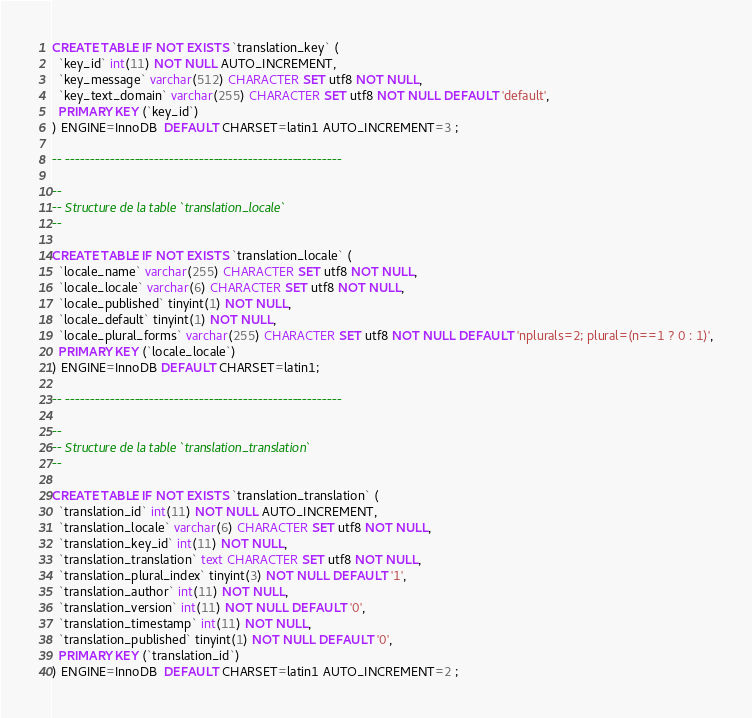Convert code to text. <code><loc_0><loc_0><loc_500><loc_500><_SQL_>
CREATE TABLE IF NOT EXISTS `translation_key` (
  `key_id` int(11) NOT NULL AUTO_INCREMENT,
  `key_message` varchar(512) CHARACTER SET utf8 NOT NULL,
  `key_text_domain` varchar(255) CHARACTER SET utf8 NOT NULL DEFAULT 'default',
  PRIMARY KEY (`key_id`)
) ENGINE=InnoDB  DEFAULT CHARSET=latin1 AUTO_INCREMENT=3 ;

-- --------------------------------------------------------

--
-- Structure de la table `translation_locale`
--

CREATE TABLE IF NOT EXISTS `translation_locale` (
  `locale_name` varchar(255) CHARACTER SET utf8 NOT NULL,
  `locale_locale` varchar(6) CHARACTER SET utf8 NOT NULL,
  `locale_published` tinyint(1) NOT NULL,
  `locale_default` tinyint(1) NOT NULL,
  `locale_plural_forms` varchar(255) CHARACTER SET utf8 NOT NULL DEFAULT 'nplurals=2; plural=(n==1 ? 0 : 1)',
  PRIMARY KEY (`locale_locale`)
) ENGINE=InnoDB DEFAULT CHARSET=latin1;

-- --------------------------------------------------------

--
-- Structure de la table `translation_translation`
--

CREATE TABLE IF NOT EXISTS `translation_translation` (
  `translation_id` int(11) NOT NULL AUTO_INCREMENT,
  `translation_locale` varchar(6) CHARACTER SET utf8 NOT NULL,
  `translation_key_id` int(11) NOT NULL,
  `translation_translation` text CHARACTER SET utf8 NOT NULL,
  `translation_plural_index` tinyint(3) NOT NULL DEFAULT '1',
  `translation_author` int(11) NOT NULL,
  `translation_version` int(11) NOT NULL DEFAULT '0',
  `translation_timestamp` int(11) NOT NULL,
  `translation_published` tinyint(1) NOT NULL DEFAULT '0',
  PRIMARY KEY (`translation_id`)
) ENGINE=InnoDB  DEFAULT CHARSET=latin1 AUTO_INCREMENT=2 ;
</code> 